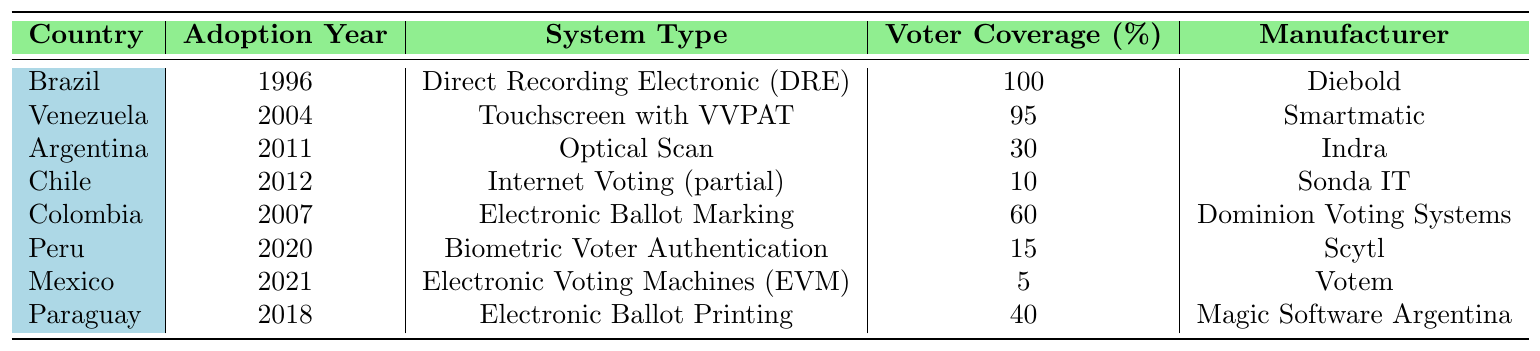What year did Brazil adopt electronic voting systems? Brazil adopted electronic voting systems in the year 1996, as stated in the table under the column for Adoption Year.
Answer: 1996 Which country implemented Biometric Voter Authentication? The table indicates that Peru implemented Biometric Voter Authentication in 2020.
Answer: Peru What is the voter coverage percentage for Argentina? According to the table, Argentina has a voter coverage percentage of 30%.
Answer: 30% Which company manufactured the electronic voting system used in Chile? The table shows that Sonda IT manufactured the electronic voting system used in Chile.
Answer: Sonda IT What is the average voter coverage percentage for the countries listed? The voter coverage percentages are 100, 95, 30, 10, 60, 15, 5, and 40. Summing these gives 100 + 95 + 30 + 10 + 60 + 15 + 5 + 40 = 455. There are 8 countries, so the average is 455 / 8 = 56.875.
Answer: 56.875 Which countries adopted electronic voting systems after 2015? The countries that adopted electronic voting systems after 2015 are Peru (2020), Mexico (2021), and Paraguay (2018). Looking at the adoption years, these are the years listed after 2015.
Answer: Peru, Mexico, Paraguay Is it true that Colombia adopted electronic voting systems before Argentina? Yes, this statement is true because Colombia adopted its system in 2007, while Argentina adopted its system in 2011.
Answer: Yes What type of electronic voting system has the highest voter coverage, and which country uses it? The system with the highest voter coverage is the Direct Recording Electronic (DRE) system used by Brazil, which has 100% voter coverage.
Answer: Direct Recording Electronic (DRE) in Brazil How many countries adopted electronic voting systems with a voter coverage percentage below 20%? The countries with voter coverage below 20% are Peru (15%) and Mexico (5%), totaling 2 countries.
Answer: 2 